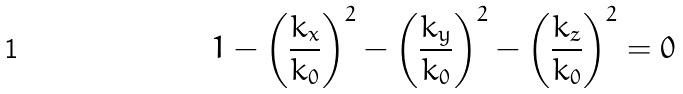Convert formula to latex. <formula><loc_0><loc_0><loc_500><loc_500>1 - \left ( \frac { k _ { x } } { k _ { 0 } } \right ) ^ { 2 } - \left ( \frac { k _ { y } } { k _ { 0 } } \right ) ^ { 2 } - \left ( \frac { k _ { z } } { k _ { 0 } } \right ) ^ { 2 } = 0</formula> 